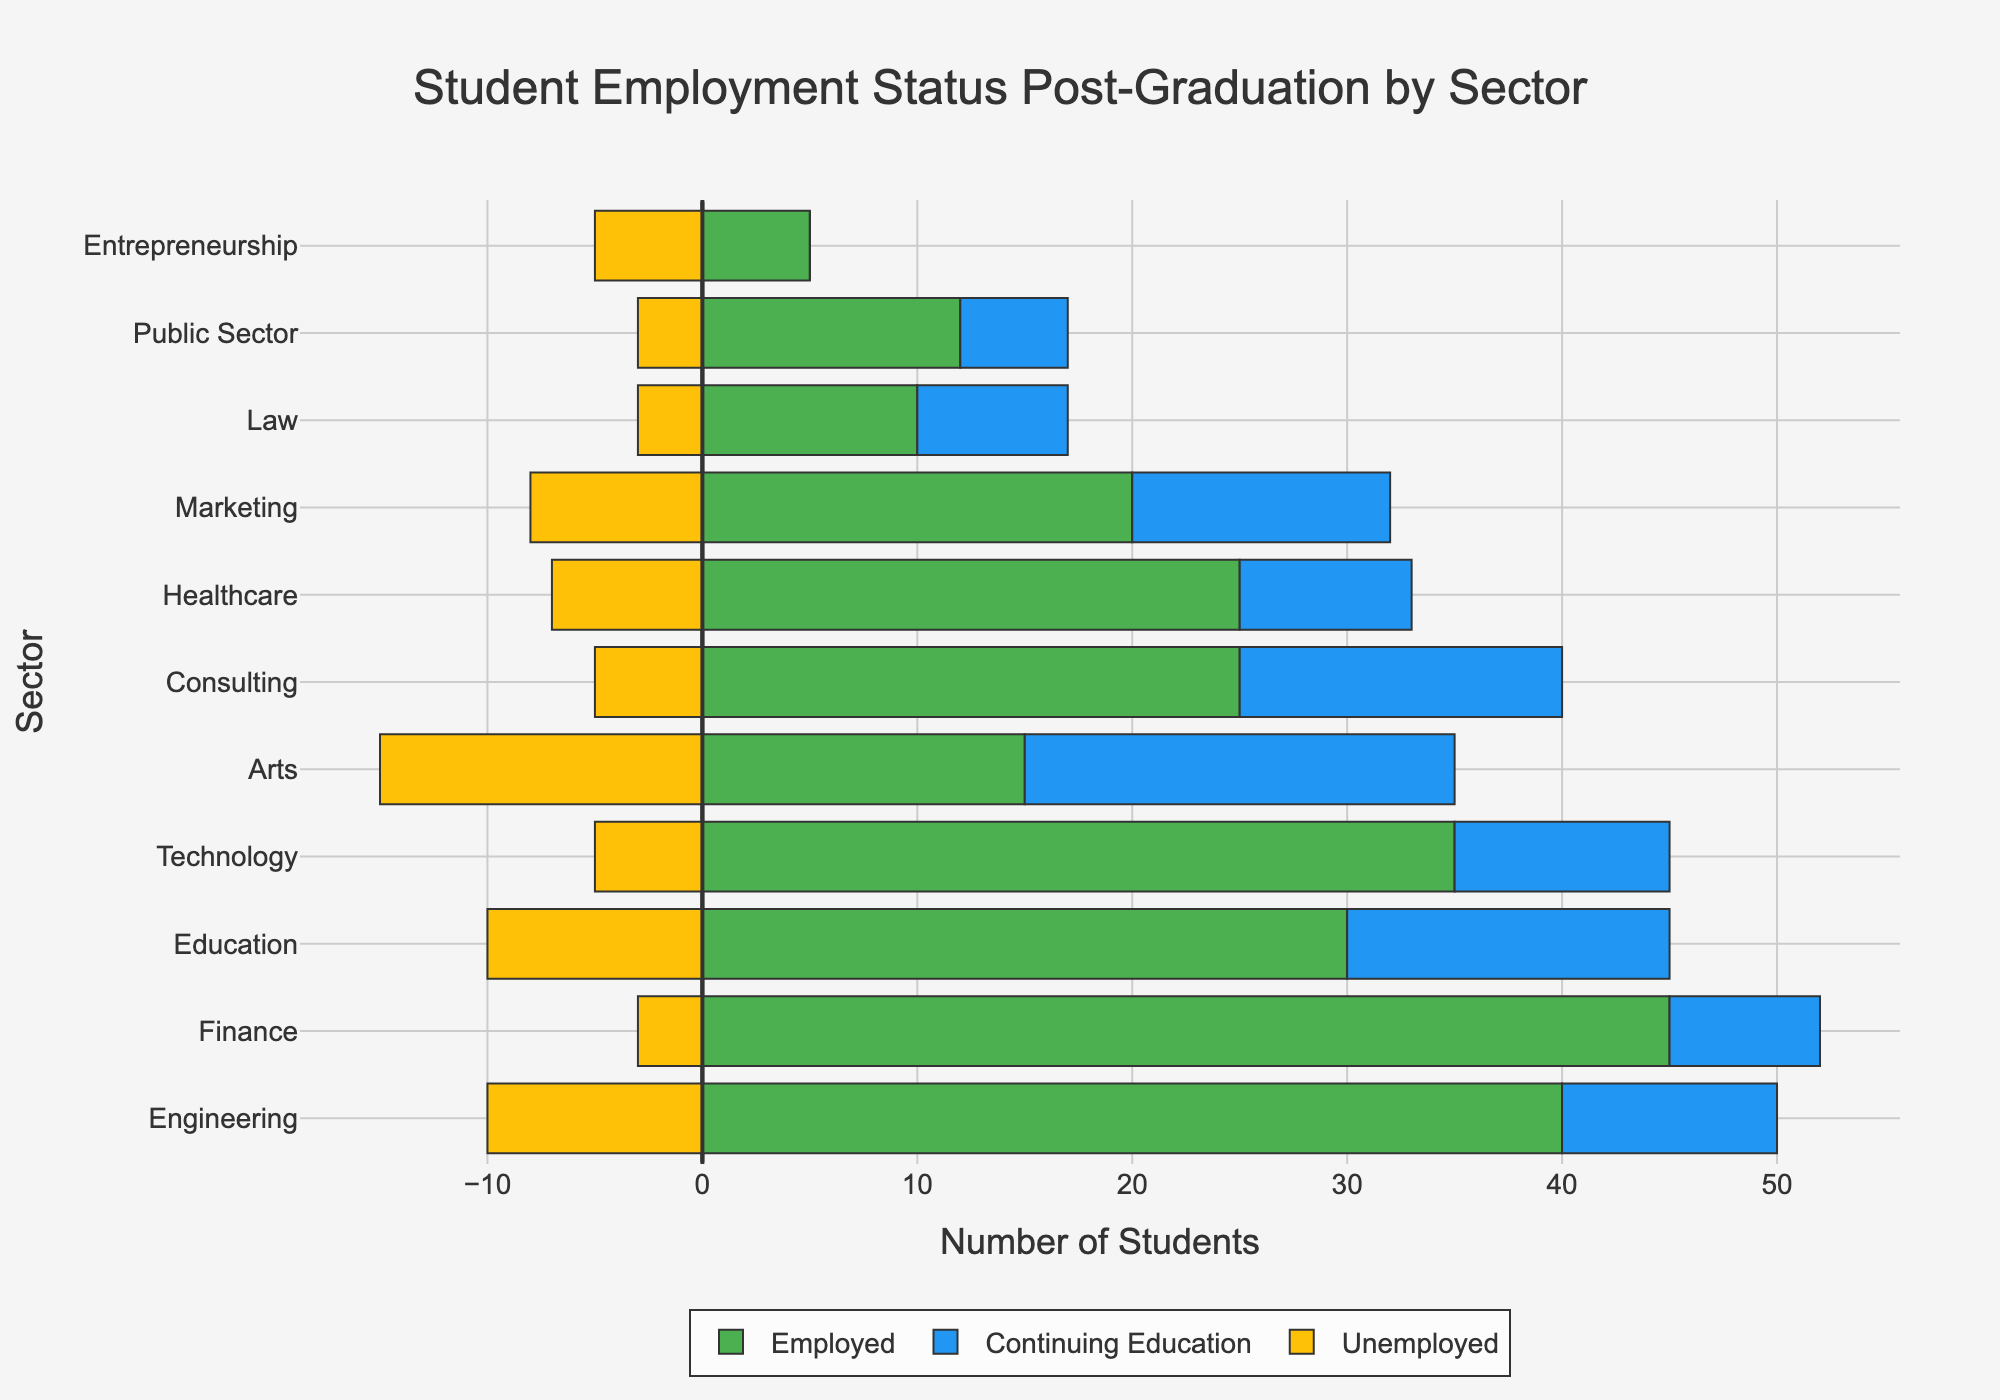Which sector has the highest number of employed students? By referring to the length of the green bars which represent employed students, we can see that the Finance sector has the longest green bar, indicating the highest number of employed students.
Answer: Finance Which sector has the highest number of unemployed students? By examining the length of the yellow bars which represent unemployed students (with negative values), the Education sector has the longest yellow bar, indicating the highest number of unemployed students.
Answer: Education How does the number of students continuing education in Technology compare to those in Healthcare? By comparing the lengths of the blue bars representing continuing education, Technology has 10 students and Healthcare has 8 students in continuing education.
Answer: Technology > Healthcare What's the combined number of employed and unemployed students in the Engineering sector? In the Engineering sector, there are 40 employed and 10 unemployed students. Adding these together gives 40 + 10 = 50.
Answer: 50 Which sector has the highest total number of students? To find the sector with the highest total number, compare the length of the combined bars for all sectors. Finance has the longest combined bar, indicating the highest total number of students.
Answer: Finance How many more employed students are there in Finance than in Law? By comparing the length of the green bars for Finance and Law, Finance has 45 employed students and Law has 10 employed students. The difference is 45 - 10 = 35.
Answer: 35 In which sector are the proportions of students continuing education and those unemployed equal? By looking for sectors where the lengths of the blue and yellow bars are equal, the Entrepreneurship sector has 0 students in continuing education and 5 unemployed, indicating equal proportions.
Answer: Entrepreneurship What's the average number of students employed across all sectors? Sum the number of employed students in all sectors (35+45+25+30+20+40+15+10+12+25+5 = 262) and divide by the number of sectors (11). The average is 262/11 = approximately 23.82.
Answer: Approximately 23.82 Which sector has the smallest proportion of unemployed students compared to the total in that sector? By calculating the proportion of unemployed students for all sectors and finding the smallest, Law has 3 unemployed out of a total of (10+7+3=20), the smallest proportion is 3/20 = 0.15 (15%).
Answer: Law 